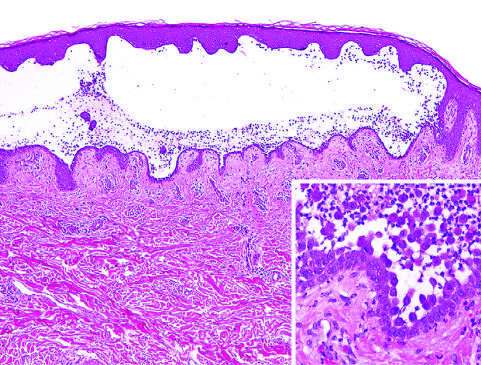re rounded, dissociated keratinocytes plentiful?
Answer the question using a single word or phrase. Yes 